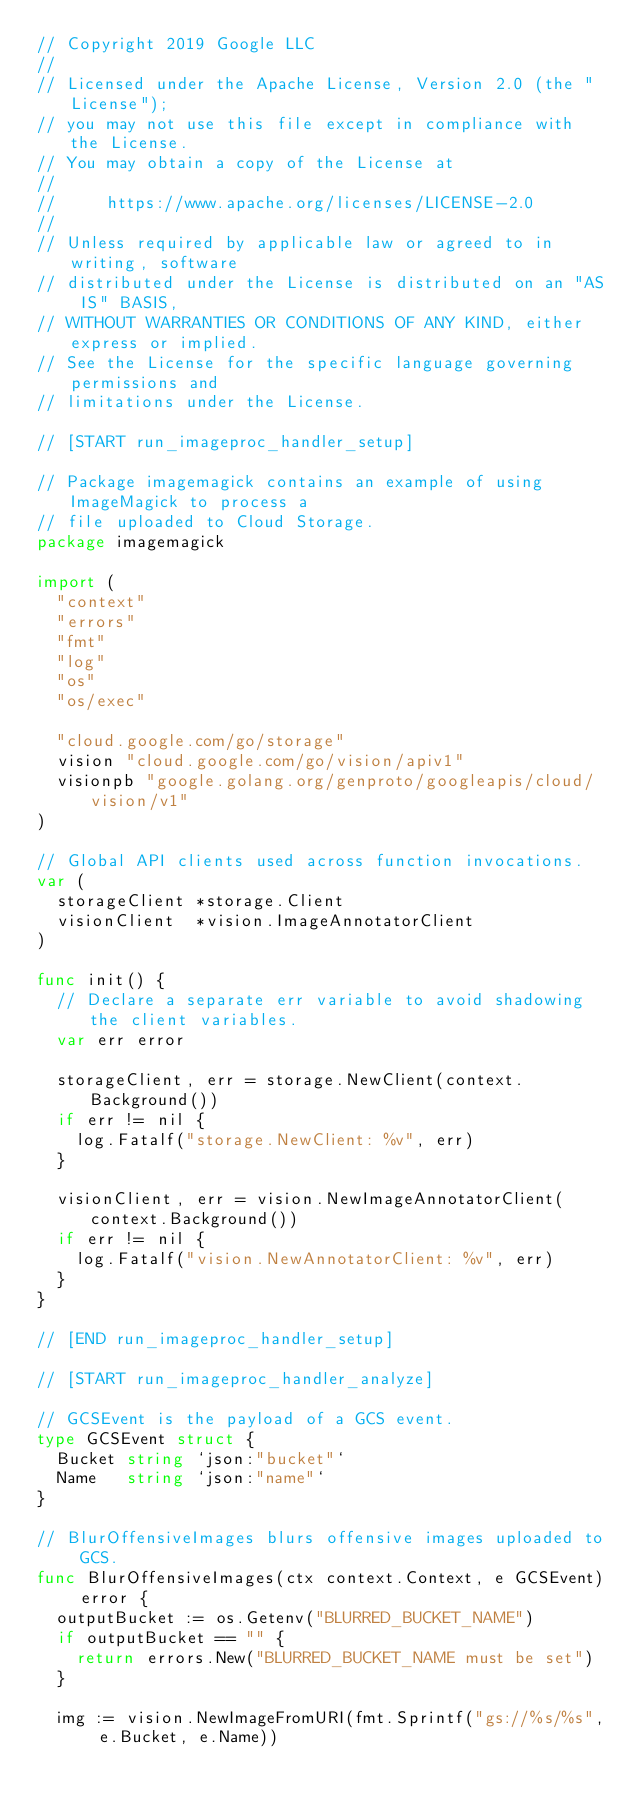Convert code to text. <code><loc_0><loc_0><loc_500><loc_500><_Go_>// Copyright 2019 Google LLC
//
// Licensed under the Apache License, Version 2.0 (the "License");
// you may not use this file except in compliance with the License.
// You may obtain a copy of the License at
//
//     https://www.apache.org/licenses/LICENSE-2.0
//
// Unless required by applicable law or agreed to in writing, software
// distributed under the License is distributed on an "AS IS" BASIS,
// WITHOUT WARRANTIES OR CONDITIONS OF ANY KIND, either express or implied.
// See the License for the specific language governing permissions and
// limitations under the License.

// [START run_imageproc_handler_setup]

// Package imagemagick contains an example of using ImageMagick to process a
// file uploaded to Cloud Storage.
package imagemagick

import (
	"context"
	"errors"
	"fmt"
	"log"
	"os"
	"os/exec"

	"cloud.google.com/go/storage"
	vision "cloud.google.com/go/vision/apiv1"
	visionpb "google.golang.org/genproto/googleapis/cloud/vision/v1"
)

// Global API clients used across function invocations.
var (
	storageClient *storage.Client
	visionClient  *vision.ImageAnnotatorClient
)

func init() {
	// Declare a separate err variable to avoid shadowing the client variables.
	var err error

	storageClient, err = storage.NewClient(context.Background())
	if err != nil {
		log.Fatalf("storage.NewClient: %v", err)
	}

	visionClient, err = vision.NewImageAnnotatorClient(context.Background())
	if err != nil {
		log.Fatalf("vision.NewAnnotatorClient: %v", err)
	}
}

// [END run_imageproc_handler_setup]

// [START run_imageproc_handler_analyze]

// GCSEvent is the payload of a GCS event.
type GCSEvent struct {
	Bucket string `json:"bucket"`
	Name   string `json:"name"`
}

// BlurOffensiveImages blurs offensive images uploaded to GCS.
func BlurOffensiveImages(ctx context.Context, e GCSEvent) error {
	outputBucket := os.Getenv("BLURRED_BUCKET_NAME")
	if outputBucket == "" {
		return errors.New("BLURRED_BUCKET_NAME must be set")
	}

	img := vision.NewImageFromURI(fmt.Sprintf("gs://%s/%s", e.Bucket, e.Name))
</code> 